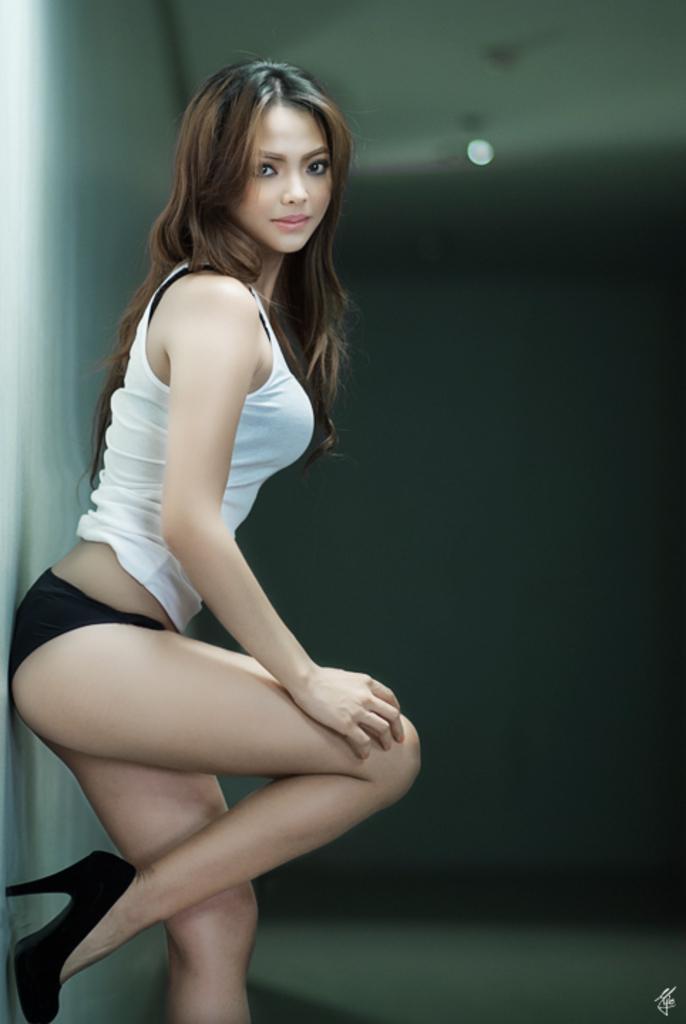Could you give a brief overview of what you see in this image? In the center of the image, we can see a lady and in the background, there is light. At the bottom, there is some text. 